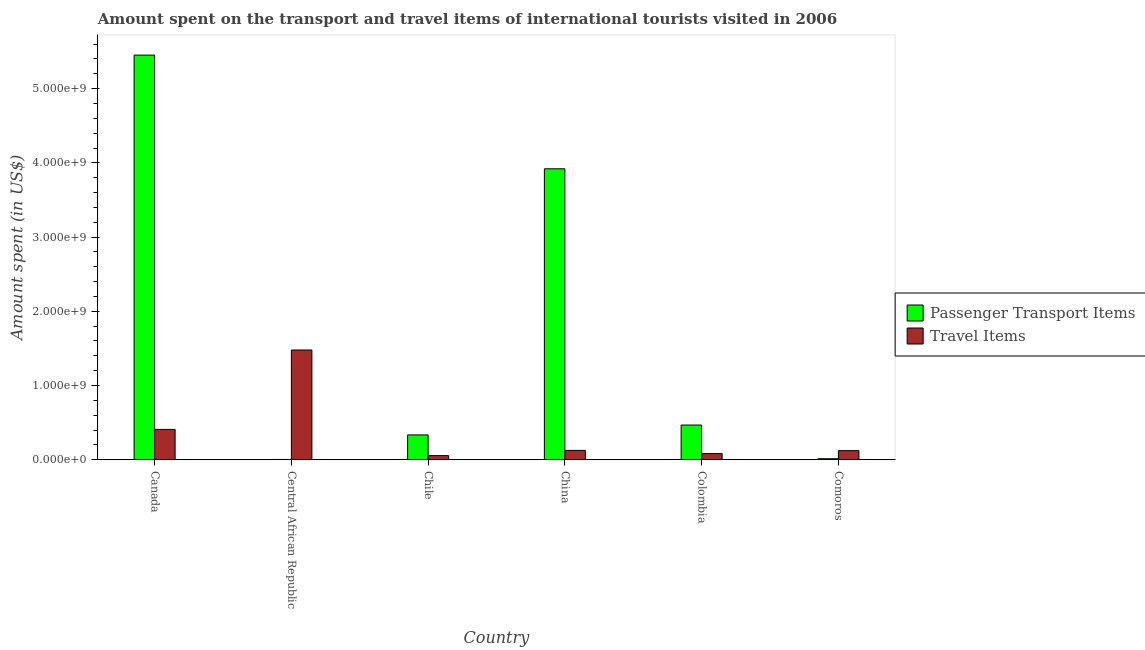How many different coloured bars are there?
Provide a succinct answer. 2. How many groups of bars are there?
Give a very brief answer. 6. How many bars are there on the 5th tick from the left?
Give a very brief answer. 2. How many bars are there on the 3rd tick from the right?
Provide a short and direct response. 2. What is the label of the 6th group of bars from the left?
Ensure brevity in your answer.  Comoros. What is the amount spent in travel items in Comoros?
Make the answer very short. 1.22e+08. Across all countries, what is the maximum amount spent in travel items?
Your answer should be compact. 1.48e+09. In which country was the amount spent in travel items maximum?
Give a very brief answer. Central African Republic. In which country was the amount spent on passenger transport items minimum?
Ensure brevity in your answer.  Central African Republic. What is the total amount spent in travel items in the graph?
Offer a terse response. 2.27e+09. What is the difference between the amount spent on passenger transport items in Canada and that in Colombia?
Offer a terse response. 4.98e+09. What is the difference between the amount spent on passenger transport items in Chile and the amount spent in travel items in Colombia?
Keep it short and to the point. 2.52e+08. What is the average amount spent in travel items per country?
Ensure brevity in your answer.  3.78e+08. What is the difference between the amount spent in travel items and amount spent on passenger transport items in China?
Your answer should be compact. -3.80e+09. In how many countries, is the amount spent on passenger transport items greater than 4600000000 US$?
Make the answer very short. 1. What is the ratio of the amount spent on passenger transport items in Central African Republic to that in Chile?
Your answer should be very brief. 0.01. Is the amount spent in travel items in Chile less than that in China?
Provide a short and direct response. Yes. What is the difference between the highest and the second highest amount spent in travel items?
Offer a terse response. 1.07e+09. What is the difference between the highest and the lowest amount spent on passenger transport items?
Your response must be concise. 5.45e+09. Is the sum of the amount spent in travel items in Canada and Colombia greater than the maximum amount spent on passenger transport items across all countries?
Offer a terse response. No. What does the 1st bar from the left in China represents?
Make the answer very short. Passenger Transport Items. What does the 1st bar from the right in Chile represents?
Make the answer very short. Travel Items. How many bars are there?
Your answer should be compact. 12. Are all the bars in the graph horizontal?
Ensure brevity in your answer.  No. Are the values on the major ticks of Y-axis written in scientific E-notation?
Your answer should be compact. Yes. Does the graph contain grids?
Provide a succinct answer. No. Where does the legend appear in the graph?
Provide a succinct answer. Center right. What is the title of the graph?
Give a very brief answer. Amount spent on the transport and travel items of international tourists visited in 2006. Does "Young" appear as one of the legend labels in the graph?
Keep it short and to the point. No. What is the label or title of the Y-axis?
Provide a short and direct response. Amount spent (in US$). What is the Amount spent (in US$) in Passenger Transport Items in Canada?
Make the answer very short. 5.45e+09. What is the Amount spent (in US$) in Travel Items in Canada?
Give a very brief answer. 4.08e+08. What is the Amount spent (in US$) in Passenger Transport Items in Central African Republic?
Provide a short and direct response. 3.00e+06. What is the Amount spent (in US$) in Travel Items in Central African Republic?
Make the answer very short. 1.48e+09. What is the Amount spent (in US$) in Passenger Transport Items in Chile?
Your answer should be compact. 3.34e+08. What is the Amount spent (in US$) in Travel Items in Chile?
Give a very brief answer. 5.50e+07. What is the Amount spent (in US$) in Passenger Transport Items in China?
Make the answer very short. 3.92e+09. What is the Amount spent (in US$) in Travel Items in China?
Provide a short and direct response. 1.25e+08. What is the Amount spent (in US$) of Passenger Transport Items in Colombia?
Offer a very short reply. 4.67e+08. What is the Amount spent (in US$) in Travel Items in Colombia?
Provide a succinct answer. 8.20e+07. What is the Amount spent (in US$) of Passenger Transport Items in Comoros?
Provide a short and direct response. 1.30e+07. What is the Amount spent (in US$) in Travel Items in Comoros?
Offer a terse response. 1.22e+08. Across all countries, what is the maximum Amount spent (in US$) in Passenger Transport Items?
Provide a short and direct response. 5.45e+09. Across all countries, what is the maximum Amount spent (in US$) of Travel Items?
Provide a short and direct response. 1.48e+09. Across all countries, what is the minimum Amount spent (in US$) of Travel Items?
Keep it short and to the point. 5.50e+07. What is the total Amount spent (in US$) of Passenger Transport Items in the graph?
Provide a short and direct response. 1.02e+1. What is the total Amount spent (in US$) of Travel Items in the graph?
Keep it short and to the point. 2.27e+09. What is the difference between the Amount spent (in US$) of Passenger Transport Items in Canada and that in Central African Republic?
Provide a succinct answer. 5.45e+09. What is the difference between the Amount spent (in US$) in Travel Items in Canada and that in Central African Republic?
Your answer should be compact. -1.07e+09. What is the difference between the Amount spent (in US$) of Passenger Transport Items in Canada and that in Chile?
Ensure brevity in your answer.  5.12e+09. What is the difference between the Amount spent (in US$) in Travel Items in Canada and that in Chile?
Make the answer very short. 3.53e+08. What is the difference between the Amount spent (in US$) in Passenger Transport Items in Canada and that in China?
Your response must be concise. 1.53e+09. What is the difference between the Amount spent (in US$) of Travel Items in Canada and that in China?
Offer a very short reply. 2.83e+08. What is the difference between the Amount spent (in US$) of Passenger Transport Items in Canada and that in Colombia?
Offer a terse response. 4.98e+09. What is the difference between the Amount spent (in US$) in Travel Items in Canada and that in Colombia?
Ensure brevity in your answer.  3.26e+08. What is the difference between the Amount spent (in US$) of Passenger Transport Items in Canada and that in Comoros?
Your response must be concise. 5.44e+09. What is the difference between the Amount spent (in US$) of Travel Items in Canada and that in Comoros?
Provide a succinct answer. 2.86e+08. What is the difference between the Amount spent (in US$) of Passenger Transport Items in Central African Republic and that in Chile?
Ensure brevity in your answer.  -3.31e+08. What is the difference between the Amount spent (in US$) in Travel Items in Central African Republic and that in Chile?
Ensure brevity in your answer.  1.42e+09. What is the difference between the Amount spent (in US$) of Passenger Transport Items in Central African Republic and that in China?
Your answer should be very brief. -3.92e+09. What is the difference between the Amount spent (in US$) of Travel Items in Central African Republic and that in China?
Offer a terse response. 1.35e+09. What is the difference between the Amount spent (in US$) in Passenger Transport Items in Central African Republic and that in Colombia?
Offer a terse response. -4.64e+08. What is the difference between the Amount spent (in US$) in Travel Items in Central African Republic and that in Colombia?
Provide a succinct answer. 1.40e+09. What is the difference between the Amount spent (in US$) in Passenger Transport Items in Central African Republic and that in Comoros?
Provide a succinct answer. -1.00e+07. What is the difference between the Amount spent (in US$) in Travel Items in Central African Republic and that in Comoros?
Ensure brevity in your answer.  1.36e+09. What is the difference between the Amount spent (in US$) in Passenger Transport Items in Chile and that in China?
Offer a very short reply. -3.59e+09. What is the difference between the Amount spent (in US$) of Travel Items in Chile and that in China?
Give a very brief answer. -7.00e+07. What is the difference between the Amount spent (in US$) of Passenger Transport Items in Chile and that in Colombia?
Your answer should be compact. -1.33e+08. What is the difference between the Amount spent (in US$) in Travel Items in Chile and that in Colombia?
Ensure brevity in your answer.  -2.70e+07. What is the difference between the Amount spent (in US$) in Passenger Transport Items in Chile and that in Comoros?
Ensure brevity in your answer.  3.21e+08. What is the difference between the Amount spent (in US$) of Travel Items in Chile and that in Comoros?
Make the answer very short. -6.70e+07. What is the difference between the Amount spent (in US$) of Passenger Transport Items in China and that in Colombia?
Keep it short and to the point. 3.45e+09. What is the difference between the Amount spent (in US$) of Travel Items in China and that in Colombia?
Ensure brevity in your answer.  4.30e+07. What is the difference between the Amount spent (in US$) in Passenger Transport Items in China and that in Comoros?
Ensure brevity in your answer.  3.91e+09. What is the difference between the Amount spent (in US$) in Passenger Transport Items in Colombia and that in Comoros?
Your response must be concise. 4.54e+08. What is the difference between the Amount spent (in US$) in Travel Items in Colombia and that in Comoros?
Keep it short and to the point. -4.00e+07. What is the difference between the Amount spent (in US$) of Passenger Transport Items in Canada and the Amount spent (in US$) of Travel Items in Central African Republic?
Give a very brief answer. 3.97e+09. What is the difference between the Amount spent (in US$) in Passenger Transport Items in Canada and the Amount spent (in US$) in Travel Items in Chile?
Keep it short and to the point. 5.40e+09. What is the difference between the Amount spent (in US$) in Passenger Transport Items in Canada and the Amount spent (in US$) in Travel Items in China?
Your answer should be very brief. 5.33e+09. What is the difference between the Amount spent (in US$) of Passenger Transport Items in Canada and the Amount spent (in US$) of Travel Items in Colombia?
Give a very brief answer. 5.37e+09. What is the difference between the Amount spent (in US$) in Passenger Transport Items in Canada and the Amount spent (in US$) in Travel Items in Comoros?
Provide a short and direct response. 5.33e+09. What is the difference between the Amount spent (in US$) in Passenger Transport Items in Central African Republic and the Amount spent (in US$) in Travel Items in Chile?
Your answer should be compact. -5.20e+07. What is the difference between the Amount spent (in US$) of Passenger Transport Items in Central African Republic and the Amount spent (in US$) of Travel Items in China?
Provide a short and direct response. -1.22e+08. What is the difference between the Amount spent (in US$) of Passenger Transport Items in Central African Republic and the Amount spent (in US$) of Travel Items in Colombia?
Provide a succinct answer. -7.90e+07. What is the difference between the Amount spent (in US$) of Passenger Transport Items in Central African Republic and the Amount spent (in US$) of Travel Items in Comoros?
Keep it short and to the point. -1.19e+08. What is the difference between the Amount spent (in US$) of Passenger Transport Items in Chile and the Amount spent (in US$) of Travel Items in China?
Ensure brevity in your answer.  2.09e+08. What is the difference between the Amount spent (in US$) of Passenger Transport Items in Chile and the Amount spent (in US$) of Travel Items in Colombia?
Keep it short and to the point. 2.52e+08. What is the difference between the Amount spent (in US$) in Passenger Transport Items in Chile and the Amount spent (in US$) in Travel Items in Comoros?
Offer a very short reply. 2.12e+08. What is the difference between the Amount spent (in US$) of Passenger Transport Items in China and the Amount spent (in US$) of Travel Items in Colombia?
Provide a succinct answer. 3.84e+09. What is the difference between the Amount spent (in US$) of Passenger Transport Items in China and the Amount spent (in US$) of Travel Items in Comoros?
Make the answer very short. 3.80e+09. What is the difference between the Amount spent (in US$) of Passenger Transport Items in Colombia and the Amount spent (in US$) of Travel Items in Comoros?
Offer a terse response. 3.45e+08. What is the average Amount spent (in US$) in Passenger Transport Items per country?
Your response must be concise. 1.70e+09. What is the average Amount spent (in US$) in Travel Items per country?
Your response must be concise. 3.78e+08. What is the difference between the Amount spent (in US$) in Passenger Transport Items and Amount spent (in US$) in Travel Items in Canada?
Make the answer very short. 5.04e+09. What is the difference between the Amount spent (in US$) of Passenger Transport Items and Amount spent (in US$) of Travel Items in Central African Republic?
Your response must be concise. -1.48e+09. What is the difference between the Amount spent (in US$) of Passenger Transport Items and Amount spent (in US$) of Travel Items in Chile?
Your answer should be compact. 2.79e+08. What is the difference between the Amount spent (in US$) of Passenger Transport Items and Amount spent (in US$) of Travel Items in China?
Keep it short and to the point. 3.80e+09. What is the difference between the Amount spent (in US$) in Passenger Transport Items and Amount spent (in US$) in Travel Items in Colombia?
Offer a terse response. 3.85e+08. What is the difference between the Amount spent (in US$) in Passenger Transport Items and Amount spent (in US$) in Travel Items in Comoros?
Your answer should be very brief. -1.09e+08. What is the ratio of the Amount spent (in US$) of Passenger Transport Items in Canada to that in Central African Republic?
Make the answer very short. 1817.33. What is the ratio of the Amount spent (in US$) in Travel Items in Canada to that in Central African Republic?
Offer a terse response. 0.28. What is the ratio of the Amount spent (in US$) in Passenger Transport Items in Canada to that in Chile?
Make the answer very short. 16.32. What is the ratio of the Amount spent (in US$) in Travel Items in Canada to that in Chile?
Offer a terse response. 7.42. What is the ratio of the Amount spent (in US$) in Passenger Transport Items in Canada to that in China?
Give a very brief answer. 1.39. What is the ratio of the Amount spent (in US$) in Travel Items in Canada to that in China?
Ensure brevity in your answer.  3.26. What is the ratio of the Amount spent (in US$) of Passenger Transport Items in Canada to that in Colombia?
Make the answer very short. 11.67. What is the ratio of the Amount spent (in US$) in Travel Items in Canada to that in Colombia?
Ensure brevity in your answer.  4.98. What is the ratio of the Amount spent (in US$) of Passenger Transport Items in Canada to that in Comoros?
Offer a terse response. 419.38. What is the ratio of the Amount spent (in US$) of Travel Items in Canada to that in Comoros?
Offer a terse response. 3.34. What is the ratio of the Amount spent (in US$) in Passenger Transport Items in Central African Republic to that in Chile?
Make the answer very short. 0.01. What is the ratio of the Amount spent (in US$) in Travel Items in Central African Republic to that in Chile?
Provide a short and direct response. 26.87. What is the ratio of the Amount spent (in US$) in Passenger Transport Items in Central African Republic to that in China?
Provide a succinct answer. 0. What is the ratio of the Amount spent (in US$) of Travel Items in Central African Republic to that in China?
Your answer should be compact. 11.82. What is the ratio of the Amount spent (in US$) of Passenger Transport Items in Central African Republic to that in Colombia?
Keep it short and to the point. 0.01. What is the ratio of the Amount spent (in US$) in Travel Items in Central African Republic to that in Colombia?
Offer a terse response. 18.02. What is the ratio of the Amount spent (in US$) of Passenger Transport Items in Central African Republic to that in Comoros?
Provide a succinct answer. 0.23. What is the ratio of the Amount spent (in US$) of Travel Items in Central African Republic to that in Comoros?
Your answer should be compact. 12.11. What is the ratio of the Amount spent (in US$) of Passenger Transport Items in Chile to that in China?
Keep it short and to the point. 0.09. What is the ratio of the Amount spent (in US$) in Travel Items in Chile to that in China?
Give a very brief answer. 0.44. What is the ratio of the Amount spent (in US$) of Passenger Transport Items in Chile to that in Colombia?
Ensure brevity in your answer.  0.72. What is the ratio of the Amount spent (in US$) in Travel Items in Chile to that in Colombia?
Your answer should be very brief. 0.67. What is the ratio of the Amount spent (in US$) in Passenger Transport Items in Chile to that in Comoros?
Keep it short and to the point. 25.69. What is the ratio of the Amount spent (in US$) of Travel Items in Chile to that in Comoros?
Offer a very short reply. 0.45. What is the ratio of the Amount spent (in US$) in Passenger Transport Items in China to that in Colombia?
Your answer should be very brief. 8.39. What is the ratio of the Amount spent (in US$) in Travel Items in China to that in Colombia?
Your response must be concise. 1.52. What is the ratio of the Amount spent (in US$) in Passenger Transport Items in China to that in Comoros?
Make the answer very short. 301.54. What is the ratio of the Amount spent (in US$) of Travel Items in China to that in Comoros?
Your answer should be compact. 1.02. What is the ratio of the Amount spent (in US$) in Passenger Transport Items in Colombia to that in Comoros?
Offer a terse response. 35.92. What is the ratio of the Amount spent (in US$) in Travel Items in Colombia to that in Comoros?
Your answer should be compact. 0.67. What is the difference between the highest and the second highest Amount spent (in US$) of Passenger Transport Items?
Keep it short and to the point. 1.53e+09. What is the difference between the highest and the second highest Amount spent (in US$) of Travel Items?
Your answer should be very brief. 1.07e+09. What is the difference between the highest and the lowest Amount spent (in US$) of Passenger Transport Items?
Make the answer very short. 5.45e+09. What is the difference between the highest and the lowest Amount spent (in US$) of Travel Items?
Provide a succinct answer. 1.42e+09. 